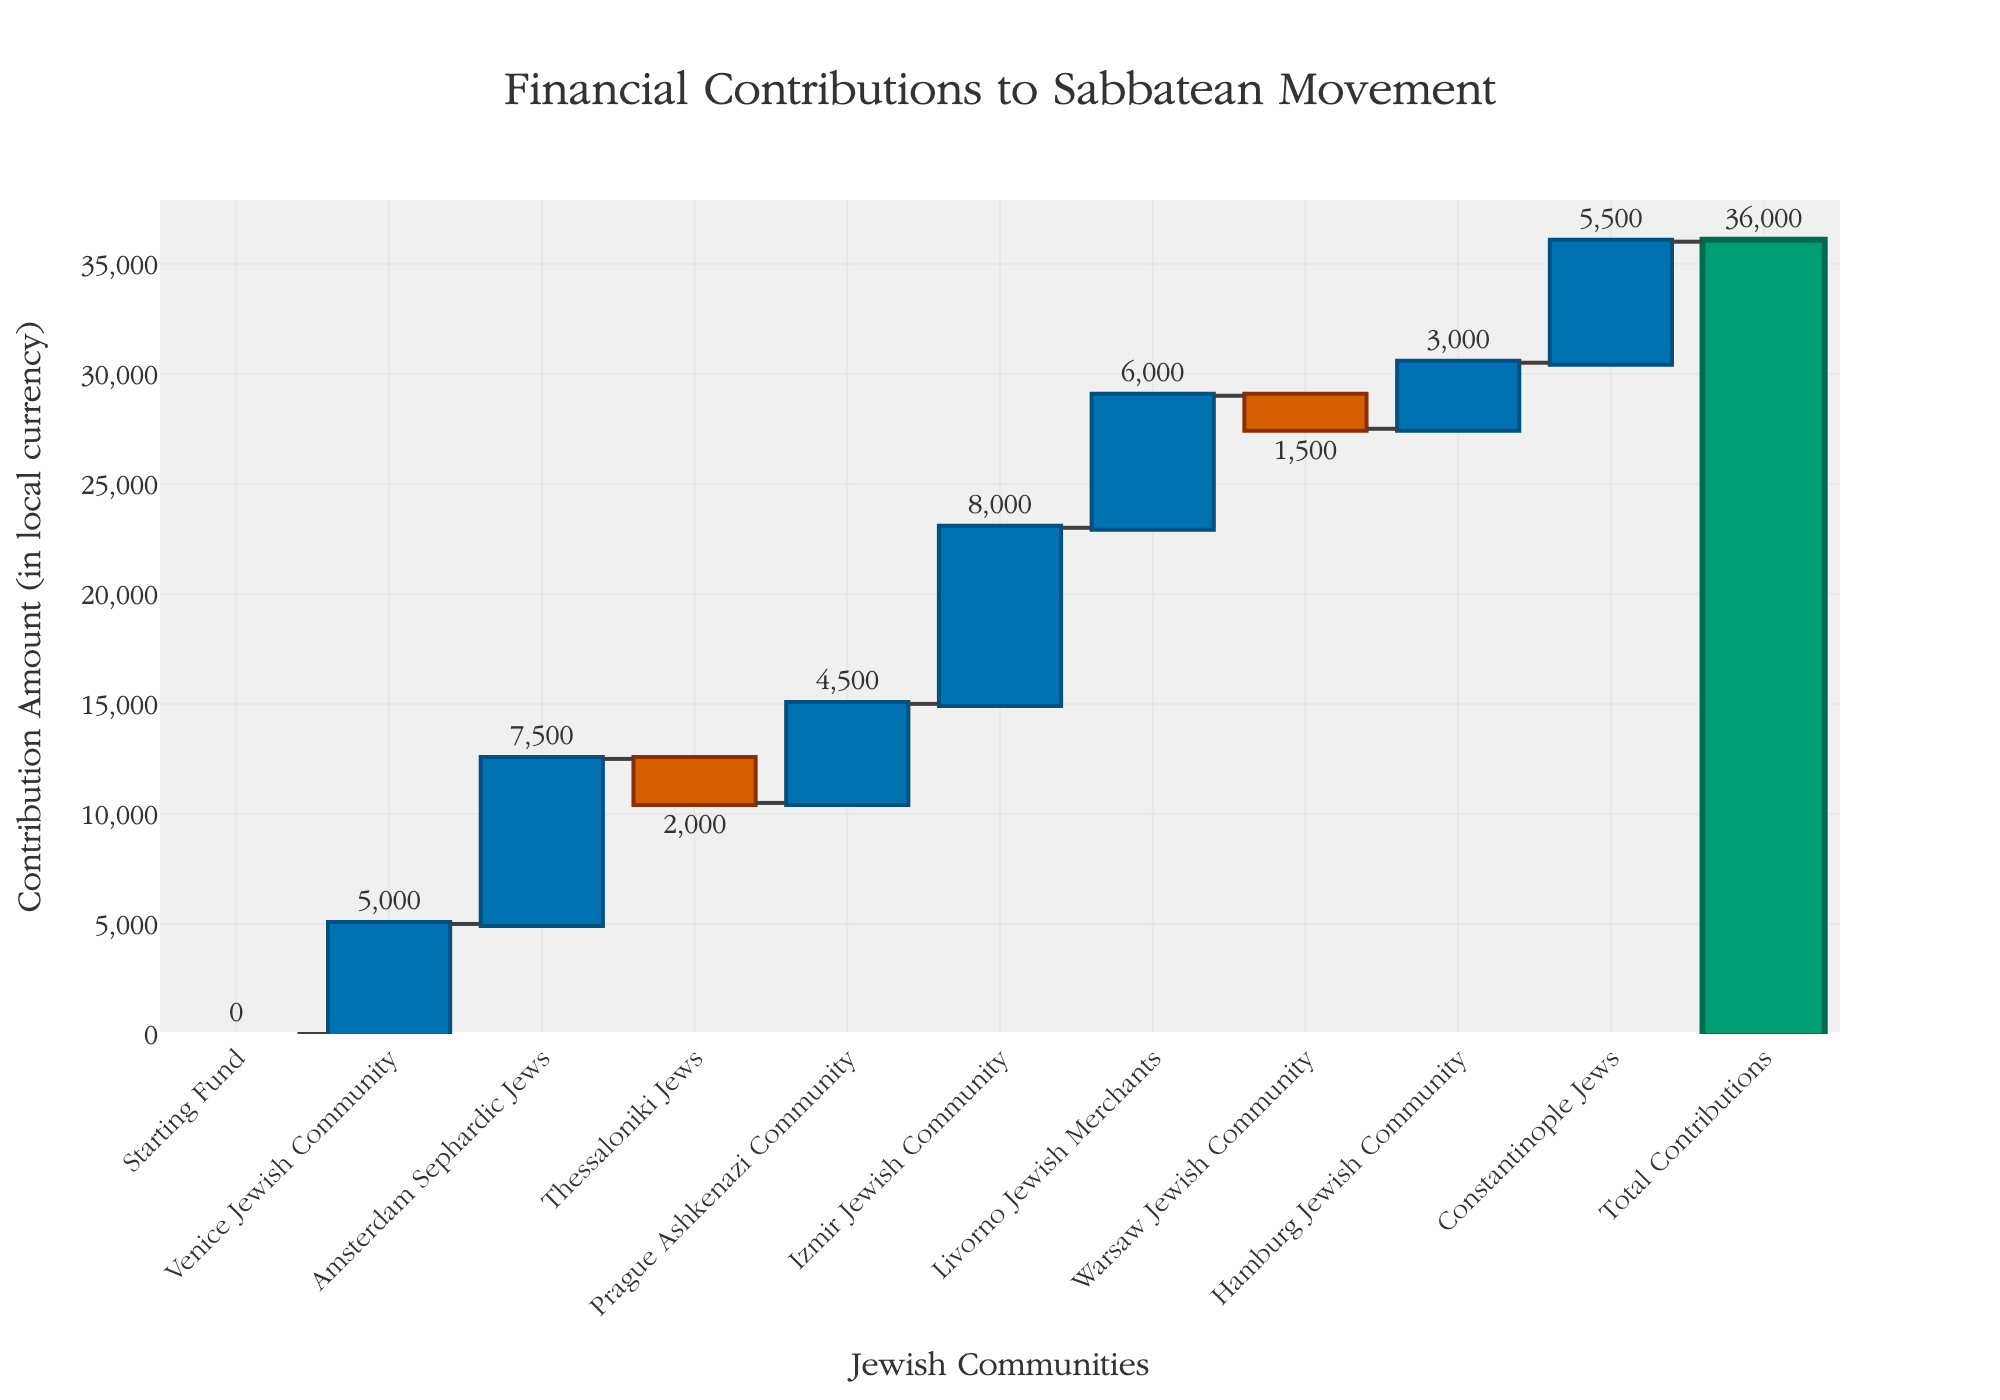How much is the total contribution to the Sabbatean movement? The 'Total Contributions' bar at the end of the chart displays the final amount: 36,000.
Answer: 36,000 Which Jewish community made the largest financial contribution? By examining the tallest bar with the highest positive value, the Izmir Jewish Community contributed the most, with 8,000 units.
Answer: Izmir Jewish Community How many communities made negative contributions, and what are their names? The two bars with negative values correspond to Thessaloniki Jews (-2,000) and Warsaw Jewish Community (-1,500).
Answer: Thessaloniki Jews, Warsaw Jewish Community What's the combined contribution of the Venice Jewish Community and the Amsterdam Sephardic Jews? Add the values of Venice Jewish Community (5,000) and Amsterdam Sephardic Jews (7,500): 5,000 + 7,500 = 12,500.
Answer: 12,500 Compare the contributions from the Prague Ashkenazi Community and Hamburg Jewish Community. How much more did one contribute than the other? Prague Ashkenazi Community contributed 4,500 and Hamburg Jewish Community contributed 3,000. The difference is 4,500 - 3,000 = 1,500.
Answer: 1,500 Which Jewish community is displayed with the first positive increase after the starting fund? The first positive bar following the starting fund is the Venice Jewish Community with 5,000 units.
Answer: Venice Jewish Community What is the median contribution value of all communities listed? Order the contribution values: -2,000, -1,500, 3,000, 4,500, 5,000, 5,500, 6,000, 7,500, 8,000. The middle value in this 9-number list is 5,500.
Answer: 5,500 How many Jewish communities made contributions greater than 6,000? The communities contributing more than 6,000 are the Amsterdam Sephardic Jews (7,500), Izmir Jewish Community (8,000), and Constantinople Jews (5,500). Thus, there are 3 counts.
Answer: 3 What is the difference between the smallest and largest contributions? The smallest contribution is -2,000 from Thessaloniki Jews, and the largest is 8,000 from Izmir Jewish Community. The difference is 8,000 - (-2,000) = 10,000.
Answer: 10,000 